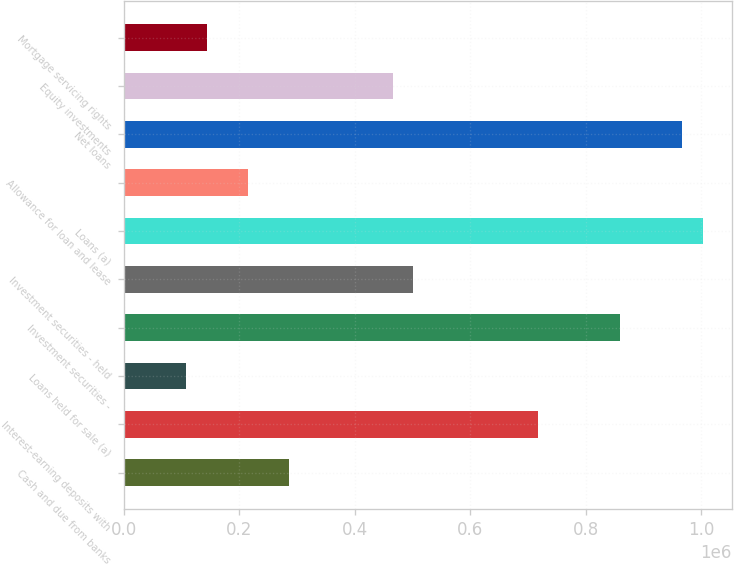Convert chart. <chart><loc_0><loc_0><loc_500><loc_500><bar_chart><fcel>Cash and due from banks<fcel>Interest-earning deposits with<fcel>Loans held for sale (a)<fcel>Investment securities -<fcel>Investment securities - held<fcel>Loans (a)<fcel>Allowance for loan and lease<fcel>Net loans<fcel>Equity investments<fcel>Mortgage servicing rights<nl><fcel>286820<fcel>716856<fcel>107639<fcel>860201<fcel>501838<fcel>1.00355e+06<fcel>215148<fcel>967710<fcel>466002<fcel>143475<nl></chart> 